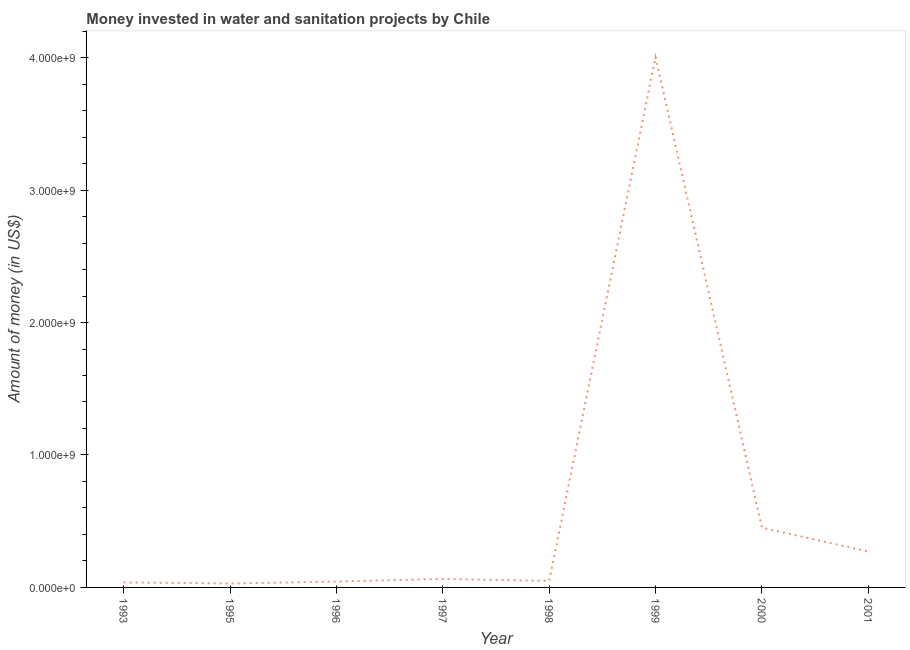What is the investment in 1997?
Keep it short and to the point. 6.40e+07. Across all years, what is the maximum investment?
Your response must be concise. 4.00e+09. Across all years, what is the minimum investment?
Offer a terse response. 2.95e+07. In which year was the investment maximum?
Your answer should be compact. 1999. In which year was the investment minimum?
Your answer should be very brief. 1995. What is the sum of the investment?
Offer a terse response. 4.95e+09. What is the difference between the investment in 1993 and 2001?
Ensure brevity in your answer.  -2.33e+08. What is the average investment per year?
Ensure brevity in your answer.  6.19e+08. What is the median investment?
Make the answer very short. 5.65e+07. What is the ratio of the investment in 1997 to that in 2001?
Your response must be concise. 0.24. Is the investment in 1997 less than that in 2000?
Ensure brevity in your answer.  Yes. What is the difference between the highest and the second highest investment?
Keep it short and to the point. 3.55e+09. What is the difference between the highest and the lowest investment?
Keep it short and to the point. 3.97e+09. How many lines are there?
Your response must be concise. 1. What is the difference between two consecutive major ticks on the Y-axis?
Your answer should be very brief. 1.00e+09. Are the values on the major ticks of Y-axis written in scientific E-notation?
Your answer should be compact. Yes. What is the title of the graph?
Your answer should be compact. Money invested in water and sanitation projects by Chile. What is the label or title of the Y-axis?
Give a very brief answer. Amount of money (in US$). What is the Amount of money (in US$) of 1993?
Make the answer very short. 3.80e+07. What is the Amount of money (in US$) in 1995?
Offer a very short reply. 2.95e+07. What is the Amount of money (in US$) in 1996?
Make the answer very short. 4.44e+07. What is the Amount of money (in US$) in 1997?
Provide a short and direct response. 6.40e+07. What is the Amount of money (in US$) in 1998?
Your answer should be very brief. 4.90e+07. What is the Amount of money (in US$) in 1999?
Make the answer very short. 4.00e+09. What is the Amount of money (in US$) of 2000?
Keep it short and to the point. 4.51e+08. What is the Amount of money (in US$) in 2001?
Your response must be concise. 2.71e+08. What is the difference between the Amount of money (in US$) in 1993 and 1995?
Provide a short and direct response. 8.50e+06. What is the difference between the Amount of money (in US$) in 1993 and 1996?
Provide a short and direct response. -6.40e+06. What is the difference between the Amount of money (in US$) in 1993 and 1997?
Provide a short and direct response. -2.60e+07. What is the difference between the Amount of money (in US$) in 1993 and 1998?
Your answer should be very brief. -1.10e+07. What is the difference between the Amount of money (in US$) in 1993 and 1999?
Offer a terse response. -3.97e+09. What is the difference between the Amount of money (in US$) in 1993 and 2000?
Offer a terse response. -4.13e+08. What is the difference between the Amount of money (in US$) in 1993 and 2001?
Provide a succinct answer. -2.33e+08. What is the difference between the Amount of money (in US$) in 1995 and 1996?
Keep it short and to the point. -1.49e+07. What is the difference between the Amount of money (in US$) in 1995 and 1997?
Provide a short and direct response. -3.45e+07. What is the difference between the Amount of money (in US$) in 1995 and 1998?
Ensure brevity in your answer.  -1.95e+07. What is the difference between the Amount of money (in US$) in 1995 and 1999?
Your answer should be compact. -3.97e+09. What is the difference between the Amount of money (in US$) in 1995 and 2000?
Your answer should be compact. -4.22e+08. What is the difference between the Amount of money (in US$) in 1995 and 2001?
Offer a very short reply. -2.42e+08. What is the difference between the Amount of money (in US$) in 1996 and 1997?
Make the answer very short. -1.96e+07. What is the difference between the Amount of money (in US$) in 1996 and 1998?
Your answer should be very brief. -4.60e+06. What is the difference between the Amount of money (in US$) in 1996 and 1999?
Your answer should be very brief. -3.96e+09. What is the difference between the Amount of money (in US$) in 1996 and 2000?
Ensure brevity in your answer.  -4.07e+08. What is the difference between the Amount of money (in US$) in 1996 and 2001?
Make the answer very short. -2.27e+08. What is the difference between the Amount of money (in US$) in 1997 and 1998?
Make the answer very short. 1.50e+07. What is the difference between the Amount of money (in US$) in 1997 and 1999?
Your answer should be compact. -3.94e+09. What is the difference between the Amount of money (in US$) in 1997 and 2000?
Offer a very short reply. -3.87e+08. What is the difference between the Amount of money (in US$) in 1997 and 2001?
Ensure brevity in your answer.  -2.07e+08. What is the difference between the Amount of money (in US$) in 1998 and 1999?
Your answer should be compact. -3.95e+09. What is the difference between the Amount of money (in US$) in 1998 and 2000?
Provide a succinct answer. -4.02e+08. What is the difference between the Amount of money (in US$) in 1998 and 2001?
Offer a very short reply. -2.22e+08. What is the difference between the Amount of money (in US$) in 1999 and 2000?
Give a very brief answer. 3.55e+09. What is the difference between the Amount of money (in US$) in 1999 and 2001?
Offer a very short reply. 3.73e+09. What is the difference between the Amount of money (in US$) in 2000 and 2001?
Your answer should be compact. 1.80e+08. What is the ratio of the Amount of money (in US$) in 1993 to that in 1995?
Your answer should be compact. 1.29. What is the ratio of the Amount of money (in US$) in 1993 to that in 1996?
Your response must be concise. 0.86. What is the ratio of the Amount of money (in US$) in 1993 to that in 1997?
Your response must be concise. 0.59. What is the ratio of the Amount of money (in US$) in 1993 to that in 1998?
Keep it short and to the point. 0.78. What is the ratio of the Amount of money (in US$) in 1993 to that in 1999?
Provide a succinct answer. 0.01. What is the ratio of the Amount of money (in US$) in 1993 to that in 2000?
Provide a short and direct response. 0.08. What is the ratio of the Amount of money (in US$) in 1993 to that in 2001?
Ensure brevity in your answer.  0.14. What is the ratio of the Amount of money (in US$) in 1995 to that in 1996?
Your answer should be very brief. 0.66. What is the ratio of the Amount of money (in US$) in 1995 to that in 1997?
Make the answer very short. 0.46. What is the ratio of the Amount of money (in US$) in 1995 to that in 1998?
Your answer should be compact. 0.6. What is the ratio of the Amount of money (in US$) in 1995 to that in 1999?
Ensure brevity in your answer.  0.01. What is the ratio of the Amount of money (in US$) in 1995 to that in 2000?
Make the answer very short. 0.07. What is the ratio of the Amount of money (in US$) in 1995 to that in 2001?
Your answer should be very brief. 0.11. What is the ratio of the Amount of money (in US$) in 1996 to that in 1997?
Give a very brief answer. 0.69. What is the ratio of the Amount of money (in US$) in 1996 to that in 1998?
Give a very brief answer. 0.91. What is the ratio of the Amount of money (in US$) in 1996 to that in 1999?
Your response must be concise. 0.01. What is the ratio of the Amount of money (in US$) in 1996 to that in 2000?
Your answer should be very brief. 0.1. What is the ratio of the Amount of money (in US$) in 1996 to that in 2001?
Your response must be concise. 0.16. What is the ratio of the Amount of money (in US$) in 1997 to that in 1998?
Ensure brevity in your answer.  1.31. What is the ratio of the Amount of money (in US$) in 1997 to that in 1999?
Offer a terse response. 0.02. What is the ratio of the Amount of money (in US$) in 1997 to that in 2000?
Your answer should be very brief. 0.14. What is the ratio of the Amount of money (in US$) in 1997 to that in 2001?
Provide a short and direct response. 0.24. What is the ratio of the Amount of money (in US$) in 1998 to that in 1999?
Your answer should be very brief. 0.01. What is the ratio of the Amount of money (in US$) in 1998 to that in 2000?
Make the answer very short. 0.11. What is the ratio of the Amount of money (in US$) in 1998 to that in 2001?
Make the answer very short. 0.18. What is the ratio of the Amount of money (in US$) in 1999 to that in 2000?
Give a very brief answer. 8.87. What is the ratio of the Amount of money (in US$) in 1999 to that in 2001?
Ensure brevity in your answer.  14.77. What is the ratio of the Amount of money (in US$) in 2000 to that in 2001?
Make the answer very short. 1.67. 